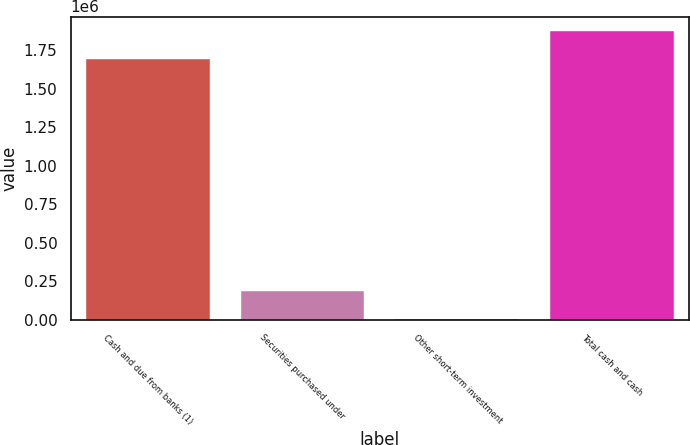Convert chart to OTSL. <chart><loc_0><loc_0><loc_500><loc_500><bar_chart><fcel>Cash and due from banks (1)<fcel>Securities purchased under<fcel>Other short-term investment<fcel>Total cash and cash<nl><fcel>1.69433e+06<fcel>185116<fcel>6122<fcel>1.87332e+06<nl></chart> 